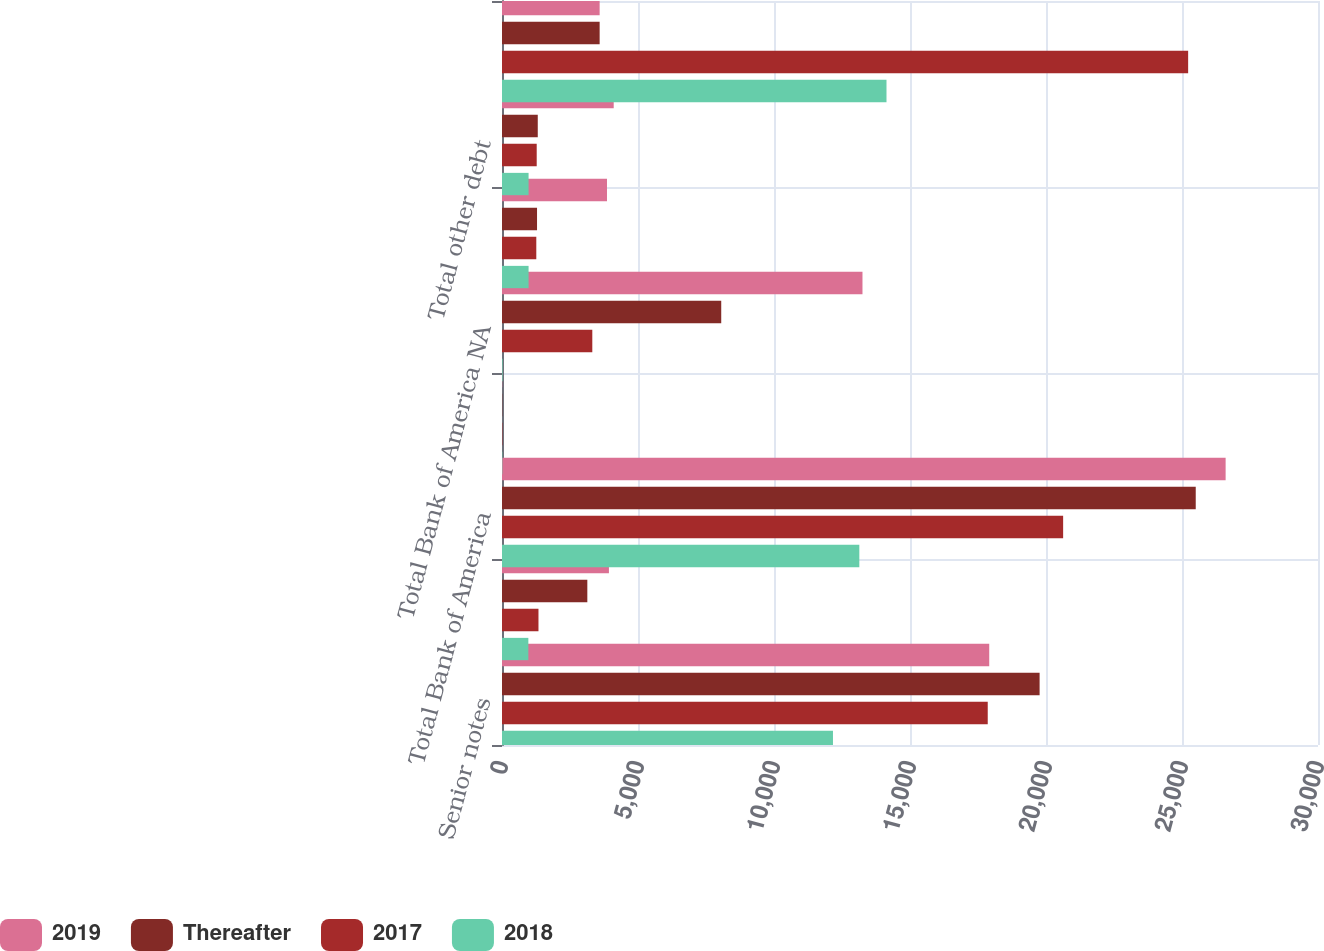<chart> <loc_0><loc_0><loc_500><loc_500><stacked_bar_chart><ecel><fcel>Senior notes<fcel>Senior structured notes<fcel>Total Bank of America<fcel>Advances from Federal Home<fcel>Total Bank of America NA<fcel>Structured liabilities<fcel>Total other debt<fcel>Total long-term debt<nl><fcel>2019<fcel>17913<fcel>3931<fcel>26604<fcel>9<fcel>13253<fcel>3860<fcel>4107<fcel>3590<nl><fcel>Thereafter<fcel>19765<fcel>3137<fcel>25505<fcel>9<fcel>8060<fcel>1288<fcel>1315<fcel>3590<nl><fcel>2017<fcel>17858<fcel>1341<fcel>20630<fcel>14<fcel>3320<fcel>1261<fcel>1276<fcel>25226<nl><fcel>2018<fcel>12168<fcel>969<fcel>13137<fcel>12<fcel>22<fcel>977<fcel>977<fcel>14136<nl></chart> 